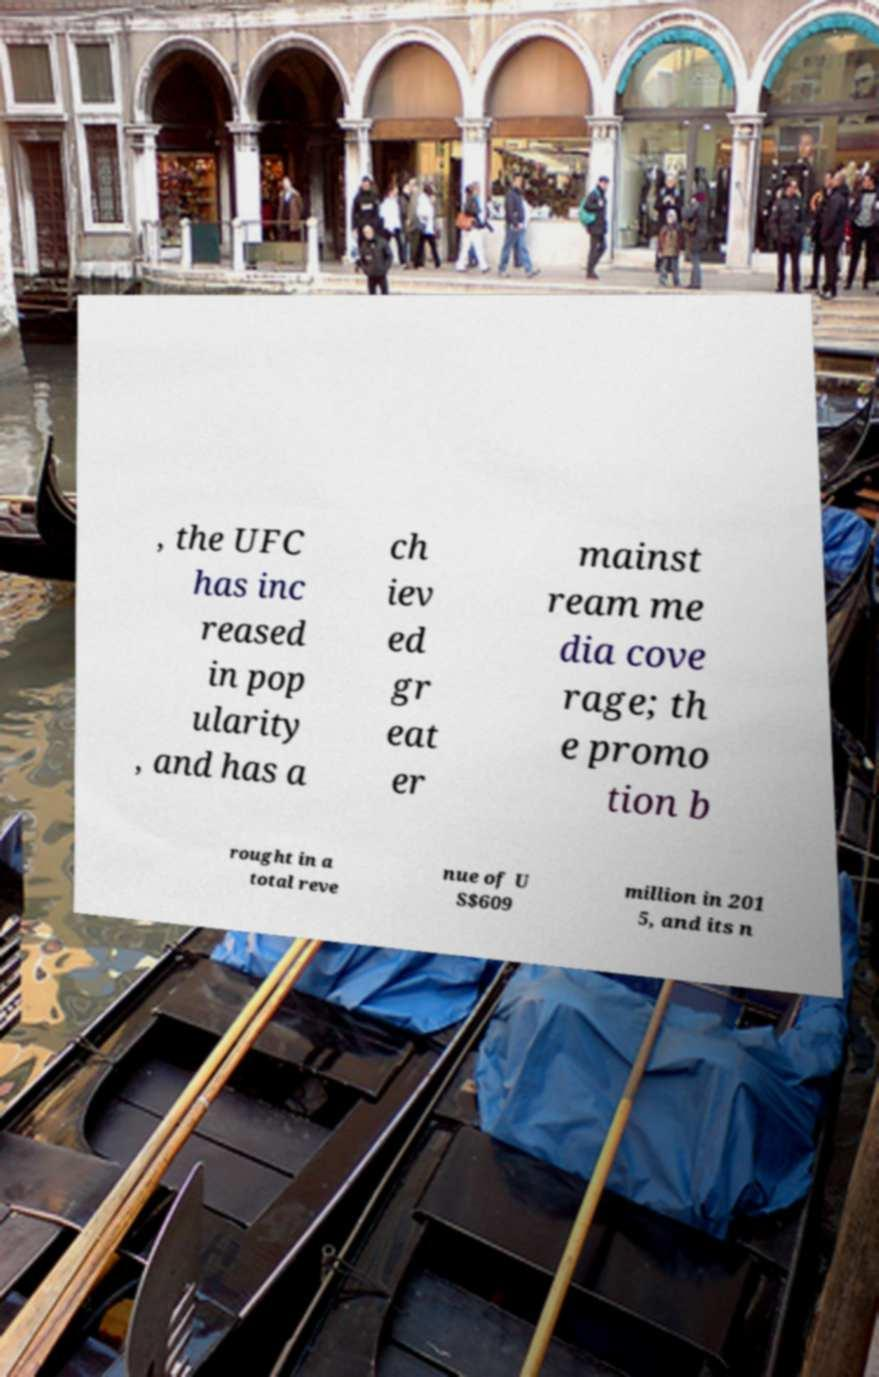What messages or text are displayed in this image? I need them in a readable, typed format. , the UFC has inc reased in pop ularity , and has a ch iev ed gr eat er mainst ream me dia cove rage; th e promo tion b rought in a total reve nue of U S$609 million in 201 5, and its n 